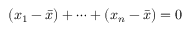<formula> <loc_0><loc_0><loc_500><loc_500>( x _ { 1 } - { \bar { x } } ) + \dots b + ( x _ { n } - { \bar { x } } ) = 0</formula> 